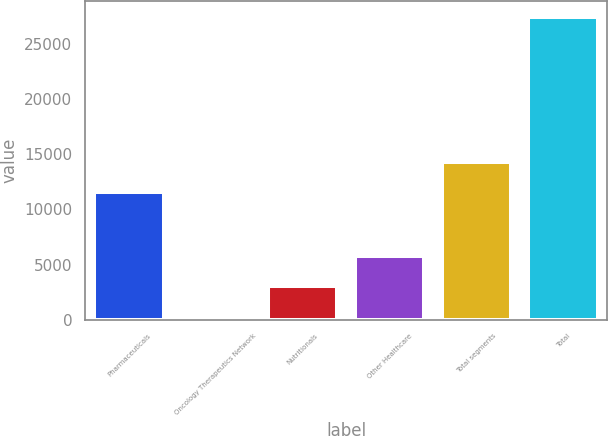Convert chart. <chart><loc_0><loc_0><loc_500><loc_500><bar_chart><fcel>Pharmaceuticals<fcel>Oncology Therapeutics Network<fcel>Nutritionals<fcel>Other Healthcare<fcel>Total segments<fcel>Total<nl><fcel>11531<fcel>307<fcel>3023.4<fcel>5739.8<fcel>14247.4<fcel>27471<nl></chart> 